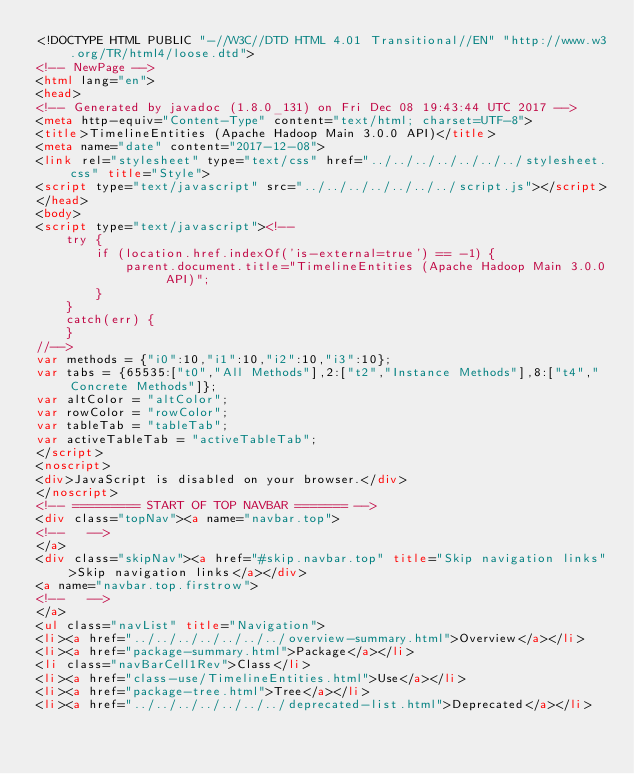<code> <loc_0><loc_0><loc_500><loc_500><_HTML_><!DOCTYPE HTML PUBLIC "-//W3C//DTD HTML 4.01 Transitional//EN" "http://www.w3.org/TR/html4/loose.dtd">
<!-- NewPage -->
<html lang="en">
<head>
<!-- Generated by javadoc (1.8.0_131) on Fri Dec 08 19:43:44 UTC 2017 -->
<meta http-equiv="Content-Type" content="text/html; charset=UTF-8">
<title>TimelineEntities (Apache Hadoop Main 3.0.0 API)</title>
<meta name="date" content="2017-12-08">
<link rel="stylesheet" type="text/css" href="../../../../../../../stylesheet.css" title="Style">
<script type="text/javascript" src="../../../../../../../script.js"></script>
</head>
<body>
<script type="text/javascript"><!--
    try {
        if (location.href.indexOf('is-external=true') == -1) {
            parent.document.title="TimelineEntities (Apache Hadoop Main 3.0.0 API)";
        }
    }
    catch(err) {
    }
//-->
var methods = {"i0":10,"i1":10,"i2":10,"i3":10};
var tabs = {65535:["t0","All Methods"],2:["t2","Instance Methods"],8:["t4","Concrete Methods"]};
var altColor = "altColor";
var rowColor = "rowColor";
var tableTab = "tableTab";
var activeTableTab = "activeTableTab";
</script>
<noscript>
<div>JavaScript is disabled on your browser.</div>
</noscript>
<!-- ========= START OF TOP NAVBAR ======= -->
<div class="topNav"><a name="navbar.top">
<!--   -->
</a>
<div class="skipNav"><a href="#skip.navbar.top" title="Skip navigation links">Skip navigation links</a></div>
<a name="navbar.top.firstrow">
<!--   -->
</a>
<ul class="navList" title="Navigation">
<li><a href="../../../../../../../overview-summary.html">Overview</a></li>
<li><a href="package-summary.html">Package</a></li>
<li class="navBarCell1Rev">Class</li>
<li><a href="class-use/TimelineEntities.html">Use</a></li>
<li><a href="package-tree.html">Tree</a></li>
<li><a href="../../../../../../../deprecated-list.html">Deprecated</a></li></code> 